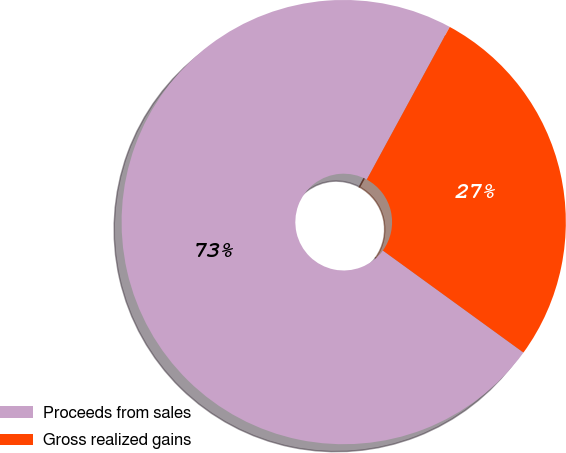Convert chart. <chart><loc_0><loc_0><loc_500><loc_500><pie_chart><fcel>Proceeds from sales<fcel>Gross realized gains<nl><fcel>72.93%<fcel>27.07%<nl></chart> 